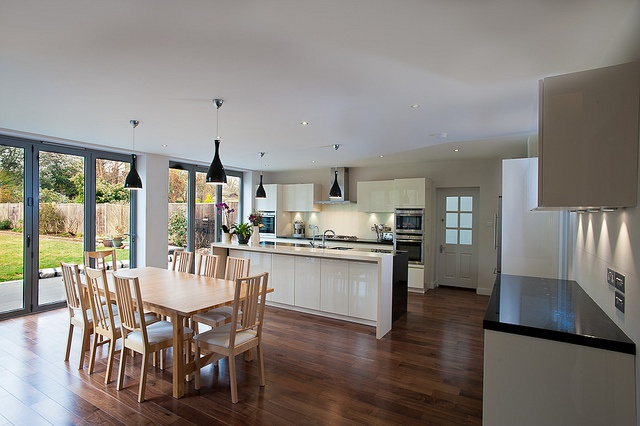Describe the objects in this image and their specific colors. I can see refrigerator in darkgray and gray tones, dining table in darkgray, lightgray, tan, and maroon tones, chair in darkgray, gray, brown, and maroon tones, chair in darkgray, maroon, and lightgray tones, and chair in darkgray, tan, lightgray, maroon, and gray tones in this image. 